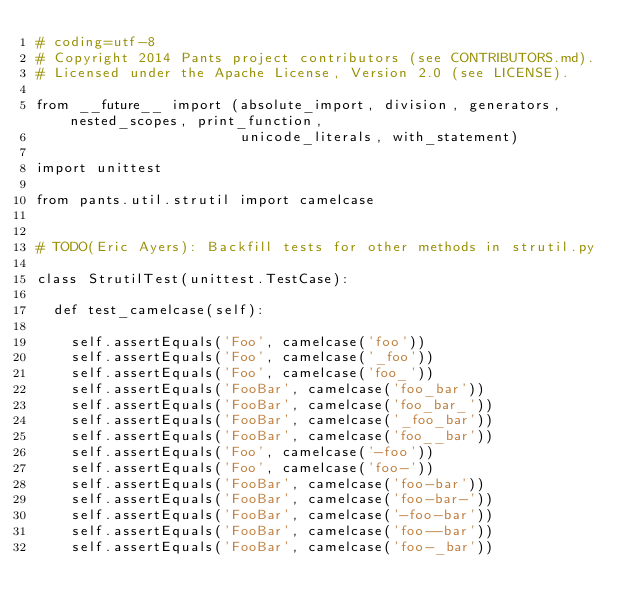Convert code to text. <code><loc_0><loc_0><loc_500><loc_500><_Python_># coding=utf-8
# Copyright 2014 Pants project contributors (see CONTRIBUTORS.md).
# Licensed under the Apache License, Version 2.0 (see LICENSE).

from __future__ import (absolute_import, division, generators, nested_scopes, print_function,
                        unicode_literals, with_statement)

import unittest

from pants.util.strutil import camelcase


# TODO(Eric Ayers): Backfill tests for other methods in strutil.py

class StrutilTest(unittest.TestCase):

  def test_camelcase(self):

    self.assertEquals('Foo', camelcase('foo'))
    self.assertEquals('Foo', camelcase('_foo'))
    self.assertEquals('Foo', camelcase('foo_'))
    self.assertEquals('FooBar', camelcase('foo_bar'))
    self.assertEquals('FooBar', camelcase('foo_bar_'))
    self.assertEquals('FooBar', camelcase('_foo_bar'))
    self.assertEquals('FooBar', camelcase('foo__bar'))
    self.assertEquals('Foo', camelcase('-foo'))
    self.assertEquals('Foo', camelcase('foo-'))
    self.assertEquals('FooBar', camelcase('foo-bar'))
    self.assertEquals('FooBar', camelcase('foo-bar-'))
    self.assertEquals('FooBar', camelcase('-foo-bar'))
    self.assertEquals('FooBar', camelcase('foo--bar'))
    self.assertEquals('FooBar', camelcase('foo-_bar'))
</code> 